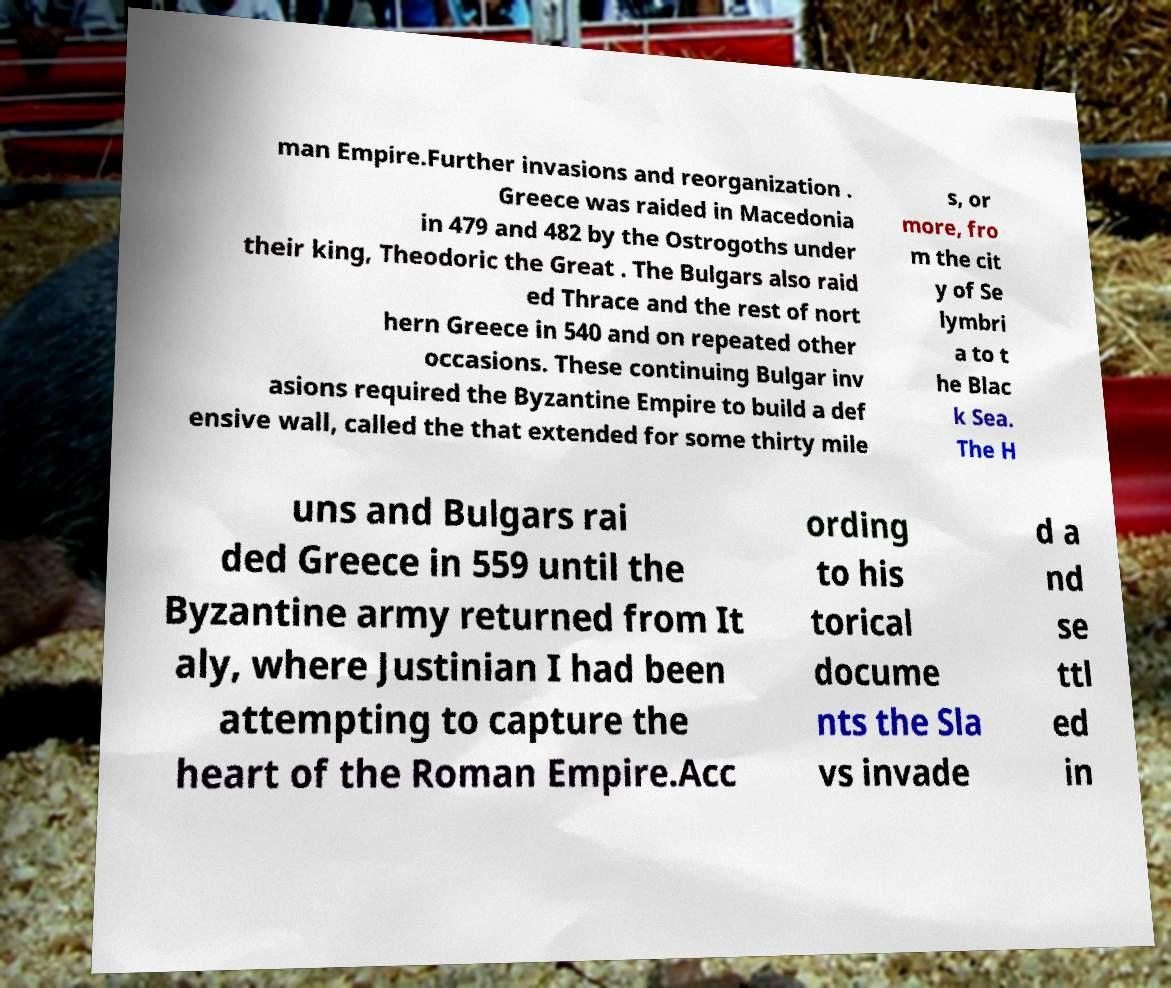Can you read and provide the text displayed in the image?This photo seems to have some interesting text. Can you extract and type it out for me? man Empire.Further invasions and reorganization . Greece was raided in Macedonia in 479 and 482 by the Ostrogoths under their king, Theodoric the Great . The Bulgars also raid ed Thrace and the rest of nort hern Greece in 540 and on repeated other occasions. These continuing Bulgar inv asions required the Byzantine Empire to build a def ensive wall, called the that extended for some thirty mile s, or more, fro m the cit y of Se lymbri a to t he Blac k Sea. The H uns and Bulgars rai ded Greece in 559 until the Byzantine army returned from It aly, where Justinian I had been attempting to capture the heart of the Roman Empire.Acc ording to his torical docume nts the Sla vs invade d a nd se ttl ed in 